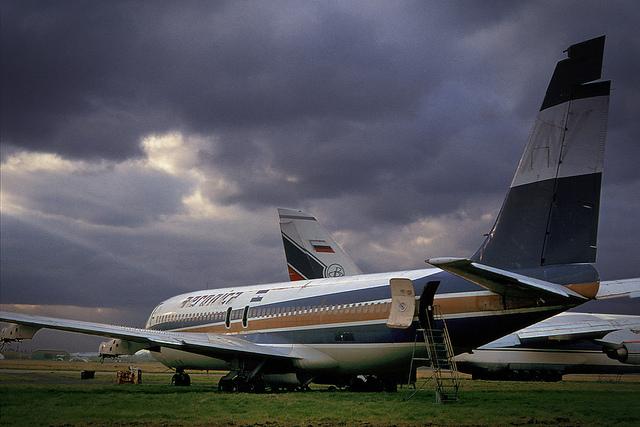Is this a good day to fly?
Concise answer only. No. Is this plane parked?
Give a very brief answer. Yes. How many planes?
Concise answer only. 2. Does this plane have a large capacity for many passengers?
Be succinct. Yes. 